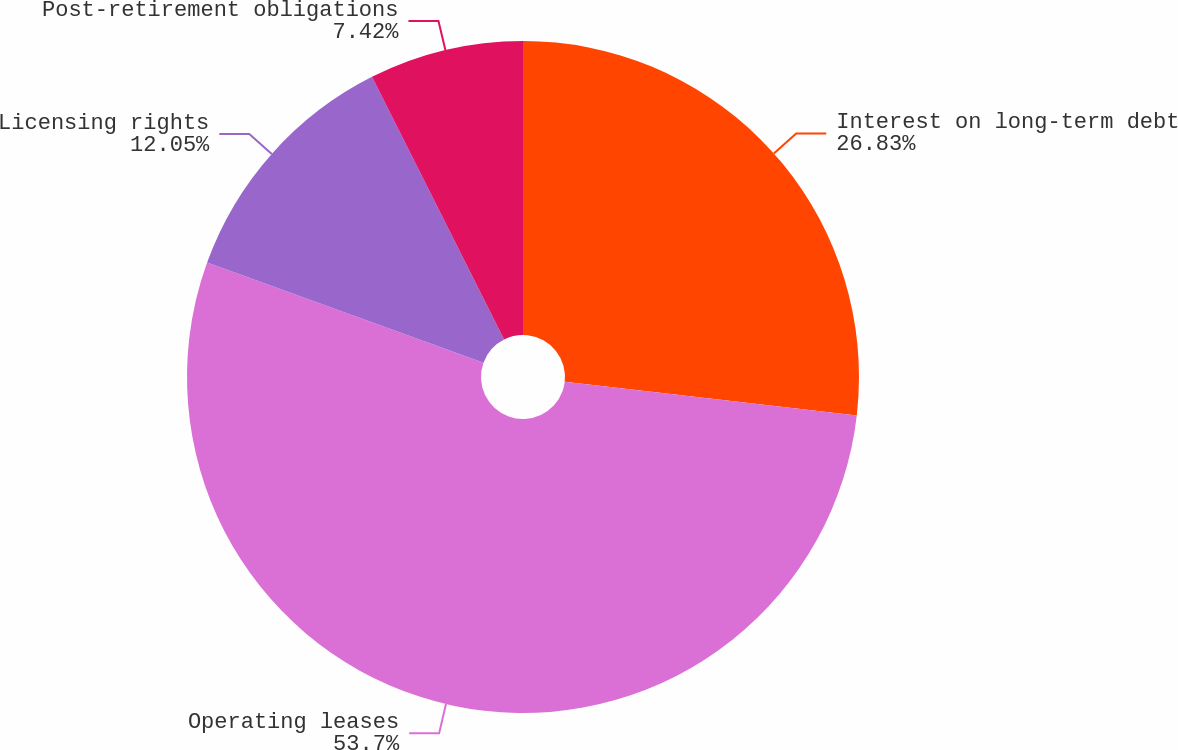<chart> <loc_0><loc_0><loc_500><loc_500><pie_chart><fcel>Interest on long-term debt<fcel>Operating leases<fcel>Licensing rights<fcel>Post-retirement obligations<nl><fcel>26.83%<fcel>53.71%<fcel>12.05%<fcel>7.42%<nl></chart> 